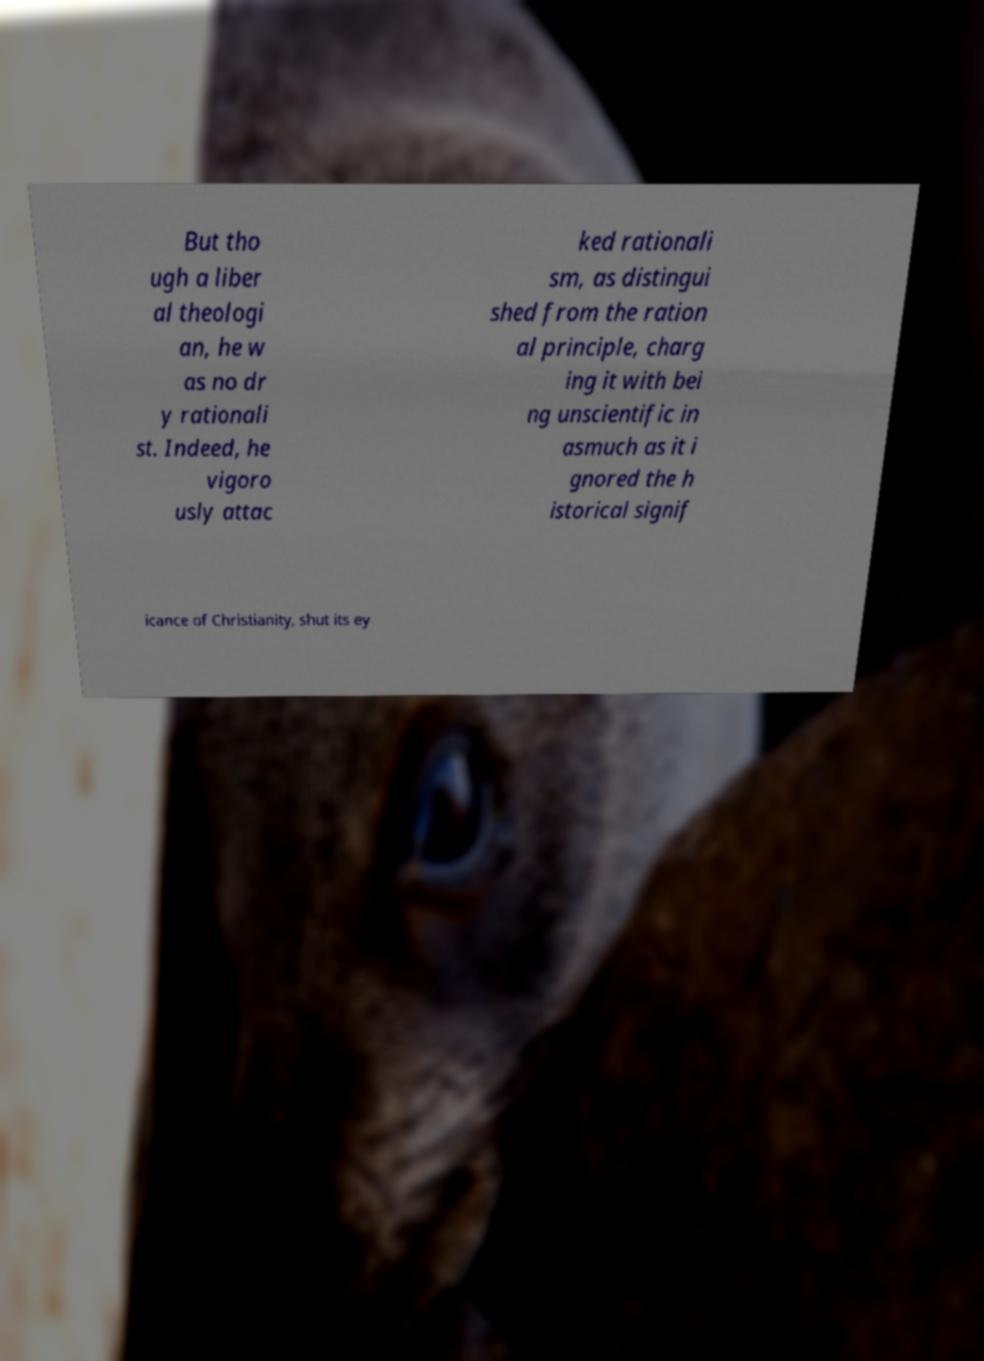Can you accurately transcribe the text from the provided image for me? But tho ugh a liber al theologi an, he w as no dr y rationali st. Indeed, he vigoro usly attac ked rationali sm, as distingui shed from the ration al principle, charg ing it with bei ng unscientific in asmuch as it i gnored the h istorical signif icance of Christianity, shut its ey 